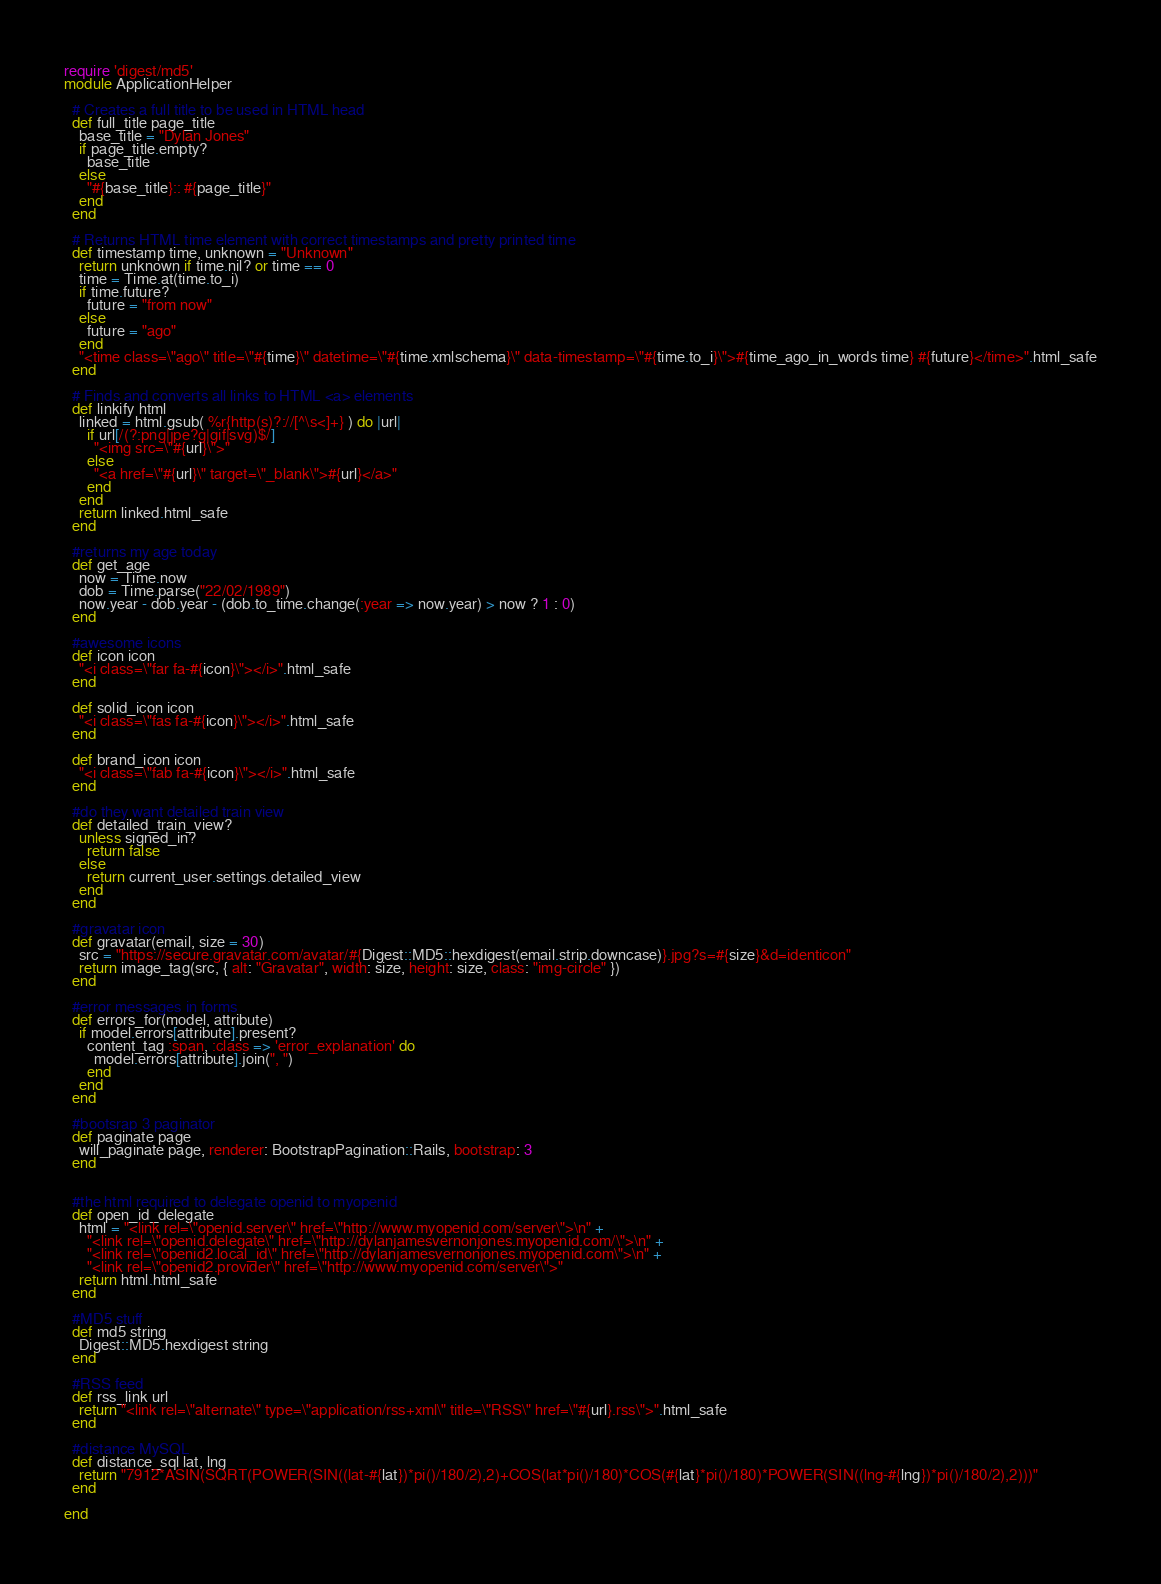<code> <loc_0><loc_0><loc_500><loc_500><_Ruby_>require 'digest/md5'
module ApplicationHelper

  # Creates a full title to be used in HTML head
  def full_title page_title
    base_title = "Dylan Jones"
    if page_title.empty?
      base_title
    else
      "#{base_title}:: #{page_title}"
    end
  end

  # Returns HTML time element with correct timestamps and pretty printed time
  def timestamp time, unknown = "Unknown"
    return unknown if time.nil? or time == 0
    time = Time.at(time.to_i)
    if time.future?
      future = "from now"
    else
      future = "ago"
    end
    "<time class=\"ago\" title=\"#{time}\" datetime=\"#{time.xmlschema}\" data-timestamp=\"#{time.to_i}\">#{time_ago_in_words time} #{future}</time>".html_safe
  end

  # Finds and converts all links to HTML <a> elements
  def linkify html
    linked = html.gsub( %r{http(s)?://[^\s<]+} ) do |url|
      if url[/(?:png|jpe?g|gif|svg)$/]
        "<img src=\"#{url}\">"
      else
        "<a href=\"#{url}\" target=\"_blank\">#{url}</a>"
      end
    end
    return linked.html_safe
  end

  #returns my age today
  def get_age
    now = Time.now
    dob = Time.parse("22/02/1989")
    now.year - dob.year - (dob.to_time.change(:year => now.year) > now ? 1 : 0)
  end

  #awesome icons
  def icon icon
    "<i class=\"far fa-#{icon}\"></i>".html_safe
  end

  def solid_icon icon
    "<i class=\"fas fa-#{icon}\"></i>".html_safe
  end

  def brand_icon icon
    "<i class=\"fab fa-#{icon}\"></i>".html_safe
  end

  #do they want detailed train view
  def detailed_train_view?
    unless signed_in?
      return false
    else
      return current_user.settings.detailed_view
    end
  end

  #gravatar icon
  def gravatar(email, size = 30)
    src = "https://secure.gravatar.com/avatar/#{Digest::MD5::hexdigest(email.strip.downcase)}.jpg?s=#{size}&d=identicon"
    return image_tag(src, { alt: "Gravatar", width: size, height: size, class: "img-circle" })
  end

  #error messages in forms
  def errors_for(model, attribute)
    if model.errors[attribute].present?
      content_tag :span, :class => 'error_explanation' do
        model.errors[attribute].join(", ")
      end
    end
  end

  #bootsrap 3 paginator
  def paginate page
    will_paginate page, renderer: BootstrapPagination::Rails, bootstrap: 3
  end


  #the html required to delegate openid to myopenid
  def open_id_delegate
    html = "<link rel=\"openid.server\" href=\"http://www.myopenid.com/server\">\n" +
      "<link rel=\"openid.delegate\" href=\"http://dylanjamesvernonjones.myopenid.com/\">\n" +
      "<link rel=\"openid2.local_id\" href=\"http://dylanjamesvernonjones.myopenid.com\">\n" +
      "<link rel=\"openid2.provider\" href=\"http://www.myopenid.com/server\">"
    return html.html_safe
  end

  #MD5 stuff
  def md5 string
    Digest::MD5.hexdigest string
  end

  #RSS feed
  def rss_link url
    return "<link rel=\"alternate\" type=\"application/rss+xml\" title=\"RSS\" href=\"#{url}.rss\">".html_safe
  end

  #distance MySQL
  def distance_sql lat, lng
    return "7912*ASIN(SQRT(POWER(SIN((lat-#{lat})*pi()/180/2),2)+COS(lat*pi()/180)*COS(#{lat}*pi()/180)*POWER(SIN((lng-#{lng})*pi()/180/2),2)))"
  end

end
</code> 